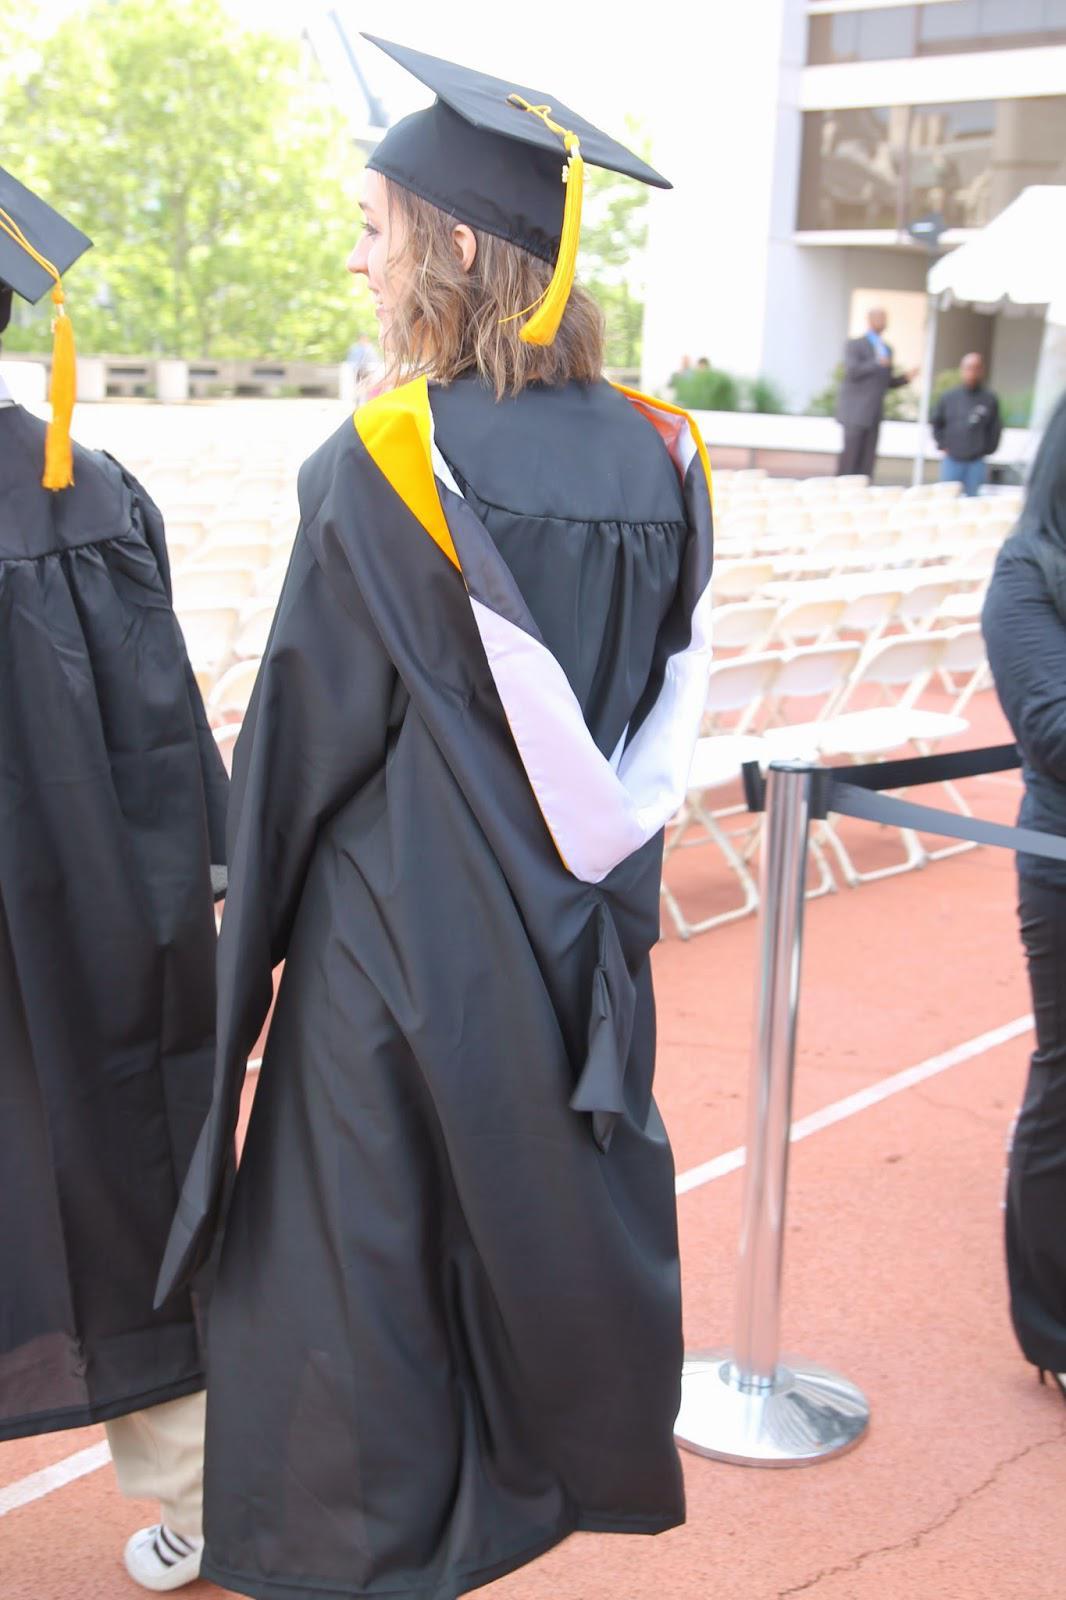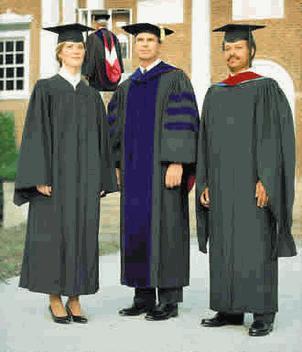The first image is the image on the left, the second image is the image on the right. Analyze the images presented: Is the assertion "a person is facing away from the camera with a light colored sash hanging down their back" valid? Answer yes or no. Yes. The first image is the image on the left, the second image is the image on the right. Given the left and right images, does the statement "One picture shows someone from the back side." hold true? Answer yes or no. Yes. 